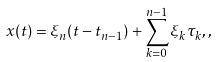Convert formula to latex. <formula><loc_0><loc_0><loc_500><loc_500>x ( t ) = \xi _ { n } ( t - t _ { n - 1 } ) + \sum _ { k = 0 } ^ { n - 1 } \xi _ { k } \tau _ { k } , ,</formula> 